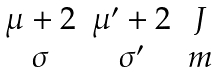Convert formula to latex. <formula><loc_0><loc_0><loc_500><loc_500>\begin{matrix} \mu + 2 & \mu ^ { \prime } + 2 & J \\ \sigma & \sigma ^ { \prime } & m \end{matrix}</formula> 